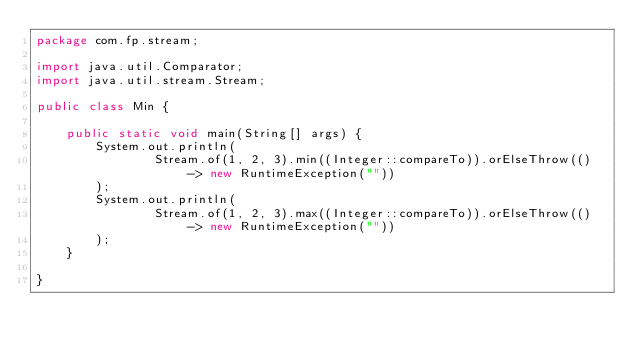<code> <loc_0><loc_0><loc_500><loc_500><_Java_>package com.fp.stream;

import java.util.Comparator;
import java.util.stream.Stream;

public class Min {

    public static void main(String[] args) {
        System.out.println(
                Stream.of(1, 2, 3).min((Integer::compareTo)).orElseThrow(() -> new RuntimeException(""))
        );
        System.out.println(
                Stream.of(1, 2, 3).max((Integer::compareTo)).orElseThrow(() -> new RuntimeException(""))
        );
    }

}
</code> 